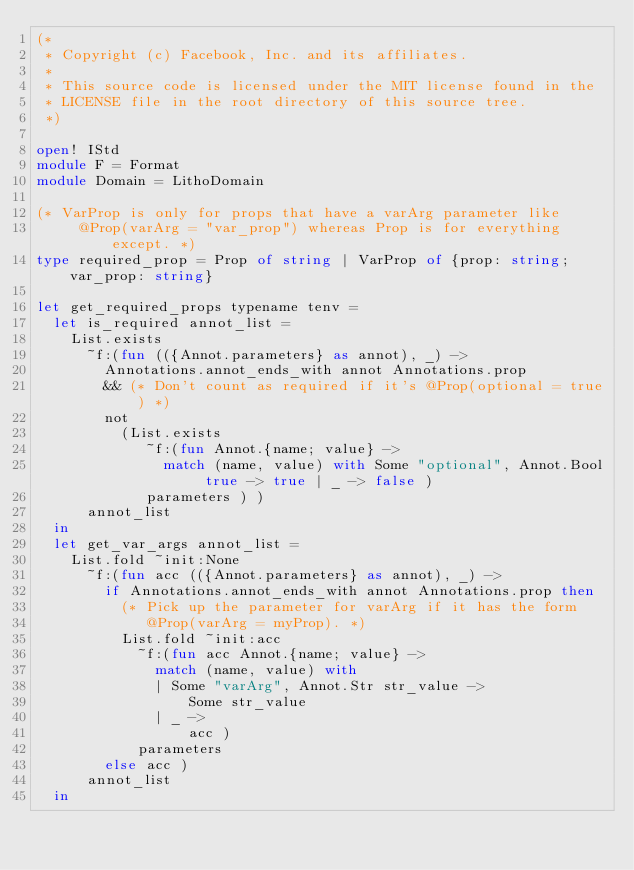Convert code to text. <code><loc_0><loc_0><loc_500><loc_500><_OCaml_>(*
 * Copyright (c) Facebook, Inc. and its affiliates.
 *
 * This source code is licensed under the MIT license found in the
 * LICENSE file in the root directory of this source tree.
 *)

open! IStd
module F = Format
module Domain = LithoDomain

(* VarProp is only for props that have a varArg parameter like
     @Prop(varArg = "var_prop") whereas Prop is for everything except. *)
type required_prop = Prop of string | VarProp of {prop: string; var_prop: string}

let get_required_props typename tenv =
  let is_required annot_list =
    List.exists
      ~f:(fun (({Annot.parameters} as annot), _) ->
        Annotations.annot_ends_with annot Annotations.prop
        && (* Don't count as required if it's @Prop(optional = true) *)
        not
          (List.exists
             ~f:(fun Annot.{name; value} ->
               match (name, value) with Some "optional", Annot.Bool true -> true | _ -> false )
             parameters ) )
      annot_list
  in
  let get_var_args annot_list =
    List.fold ~init:None
      ~f:(fun acc (({Annot.parameters} as annot), _) ->
        if Annotations.annot_ends_with annot Annotations.prop then
          (* Pick up the parameter for varArg if it has the form
             @Prop(varArg = myProp). *)
          List.fold ~init:acc
            ~f:(fun acc Annot.{name; value} ->
              match (name, value) with
              | Some "varArg", Annot.Str str_value ->
                  Some str_value
              | _ ->
                  acc )
            parameters
        else acc )
      annot_list
  in</code> 